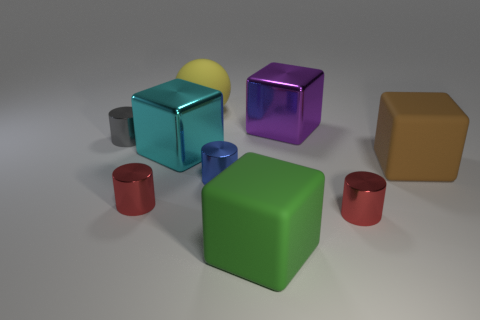Subtract all purple shiny blocks. How many blocks are left? 3 Subtract all purple blocks. How many blocks are left? 3 Subtract all brown cubes. How many red cylinders are left? 2 Subtract 3 blocks. How many blocks are left? 1 Subtract all blocks. How many objects are left? 5 Subtract all big green rubber blocks. Subtract all green rubber blocks. How many objects are left? 7 Add 6 tiny gray things. How many tiny gray things are left? 7 Add 4 large purple metal things. How many large purple metal things exist? 5 Subtract 0 green balls. How many objects are left? 9 Subtract all gray cylinders. Subtract all blue spheres. How many cylinders are left? 3 